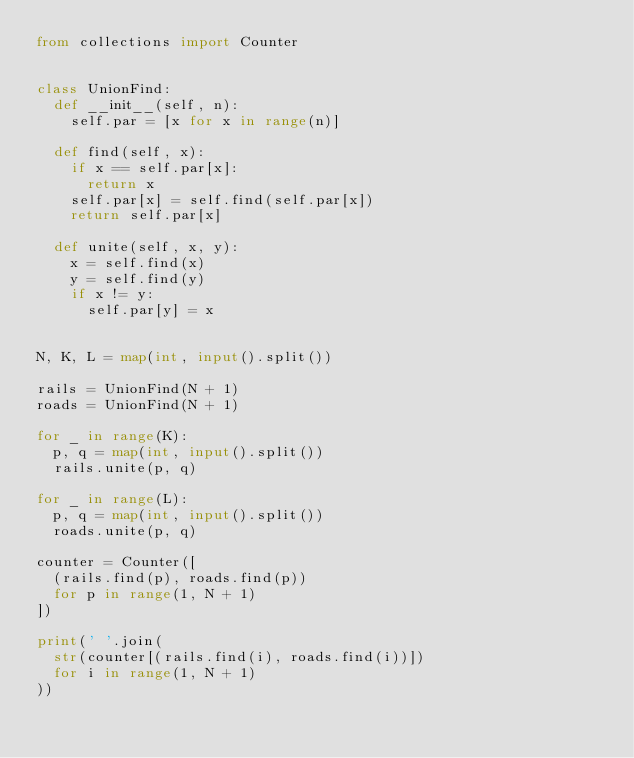<code> <loc_0><loc_0><loc_500><loc_500><_Python_>from collections import Counter


class UnionFind:
  def __init__(self, n):
    self.par = [x for x in range(n)]
    
  def find(self, x):
    if x == self.par[x]:
      return x
    self.par[x] = self.find(self.par[x])
    return self.par[x]
  
  def unite(self, x, y):
    x = self.find(x)
    y = self.find(y)
    if x != y:
      self.par[y] = x

      
N, K, L = map(int, input().split())  

rails = UnionFind(N + 1)
roads = UnionFind(N + 1)

for _ in range(K):
  p, q = map(int, input().split())
  rails.unite(p, q)

for _ in range(L):
  p, q = map(int, input().split())
  roads.unite(p, q)

counter = Counter([
  (rails.find(p), roads.find(p))
  for p in range(1, N + 1)
])

print(' '.join(
  str(counter[(rails.find(i), roads.find(i))])
  for i in range(1, N + 1)
))   </code> 